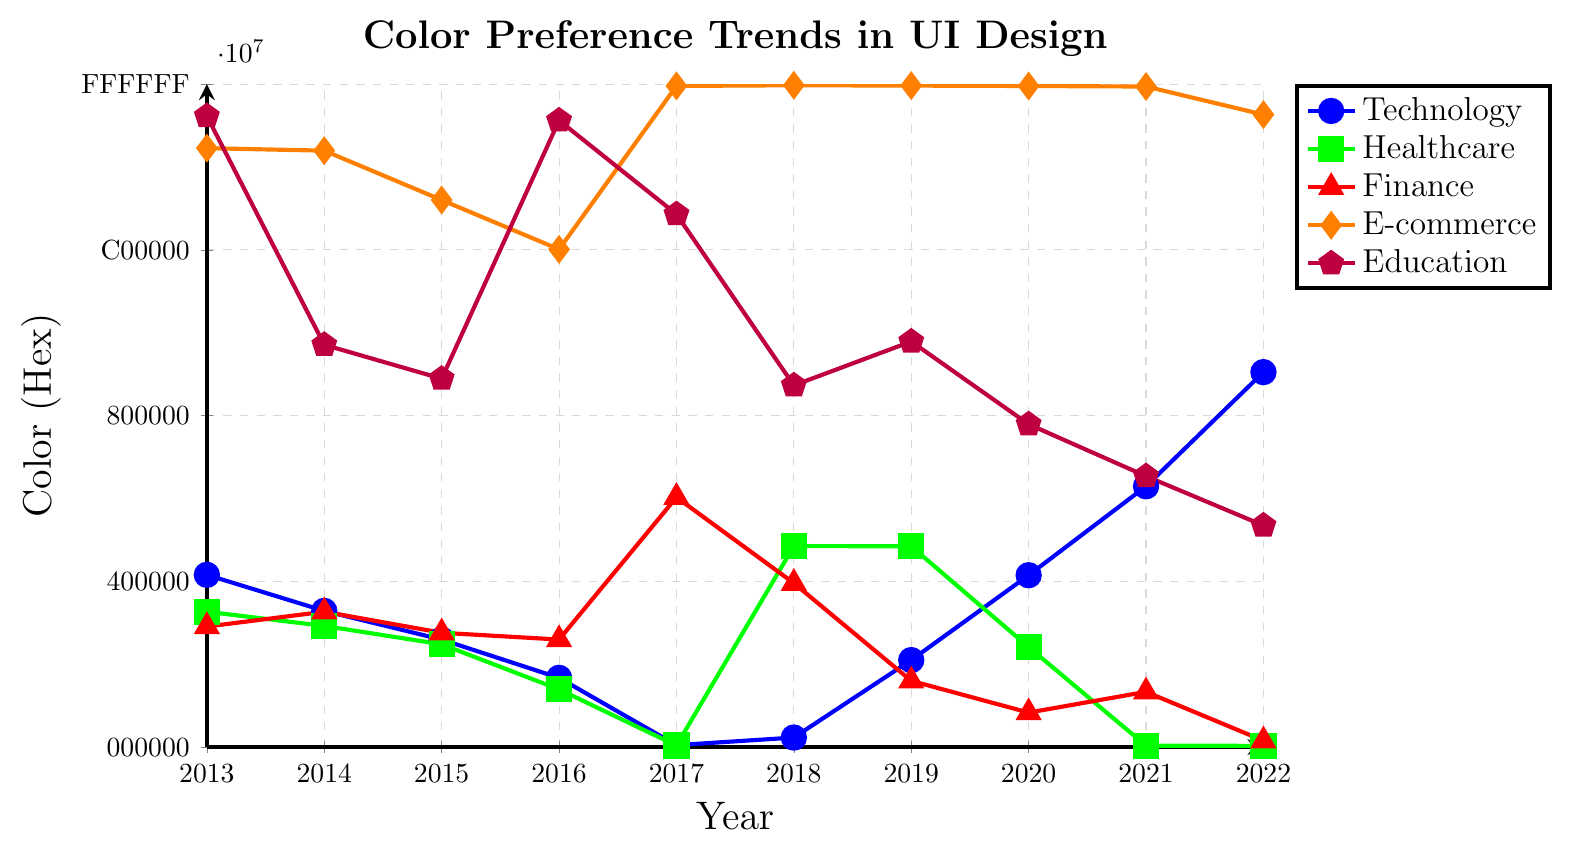Which industry sector favored the color blue the most consistently over the past decade? By examining the plot, we can see that the Technology sector is consistently marked near the blue hue over the years. This is evident from the points in this sector usually placed at the lower part of the y-axis, which represents closer to blue in color hex codes.
Answer: Technology Between Technology and Finance, which sector showed a more significant shift in color preference over the past decade? Observe the y-axis variation for both sectors' lines. The Finance sector shows a larger range of y-values (from red to blue), while the Technology sector remains more consistent in the blue-to-green range. Therefore, Finance experienced a more significant shift.
Answer: Finance Did the E-commerce sector's color preference trend show a strong consistent pattern over the decade? The E-commerce sector's color preference starts in a red hue and ends roughly in the same area, showing minor fluctuations, indicating a strong consistent trend. This is observed by its line hardly deviating up or down the y-axis drastically.
Answer: Yes In which year did the Education sector use a color closely aligned with the yellow-green hue? The yellow-green hue appears at a higher y-axis value close to "CDDC39". In 2017, the line for Education reaches the highest point, indicating a color closely aligned with yellow-green.
Answer: 2017 Which sector had the most varied color preference trend over the years? The Healthcare sector has a line that oscillates the most between the low and high y-axis ends, indicating varied color preferences ranging from green to blue to other colors.
Answer: Healthcare Did any industry sectors converge to a similar color preference in recent years, particularly in 2022? In 2022, observe that sectors shown in the plot somewhat stabilize. Both Healthcare and Finance move towards a darker green color, converging closely compared to other years. This is deduced by their coordinates at the higher y-values in 2022.
Answer: Healthcare, Finance What was the prevalent color trend for Finance in the middle of the decade, around 2016-2018? Between 2016 and 2018, observe the colored line for Finance hovering lower in the y-axis towards blue, indicating a prevalent trend of blue color preference.
Answer: Blue Which year saw the biggest upward color preference shift for the Healthcare sector? In the Healthcare sector, the sharpest upward movement on the plot is between 2016 and 2017, indicating a significant color preference shift from green to yellow.
Answer: 2017 Compare the color trends of Technology and E-Commerce sectors in 2015. Which one preferred a color closer to red? For comparison, in 2015, view the relative positions on the y-axis. The E-commerce sector's y-coordinate is higher and closer to red hues, whereas the Technology sector's point is at a lower value closer to blue and green hues.
Answer: E-commerce In which year did all sectors display their most distinct and varied color preferences, without overlapping trends? Each sector line in the plot is analyzed for the widest spread along the y-axis in a particular year. In 2013, the sectors' trends are most varied and do not overlap significantly.
Answer: 2013 